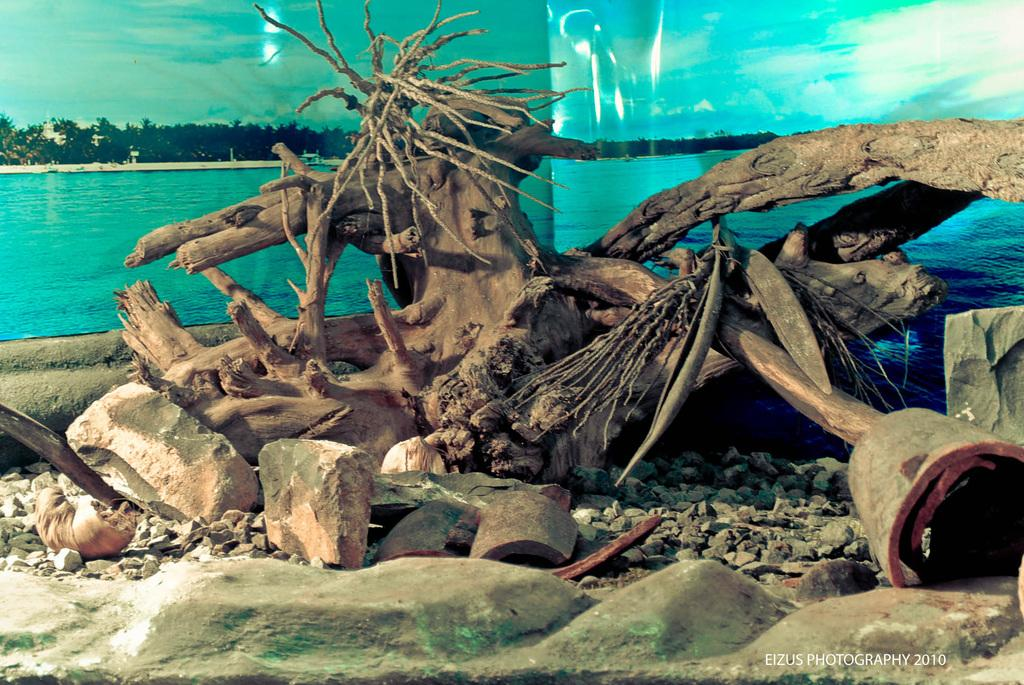What type of natural elements can be seen in the image? Tree trunks, stones, trees, water, ground, and sky are visible in the image. What is the condition of the sky in the image? The sky is visible in the image, and clouds are present. Can you describe the objects in the image? Unfortunately, the provided facts do not specify the nature of the objects in the image. What type of terrain is visible in the image? The image shows a combination of natural elements, including tree trunks, stones, trees, water, and ground. What type of breakfast is being prepared on the tree trunks in the image? There is no indication of any breakfast preparation in the image, as it primarily features natural elements such as tree trunks, stones, trees, water, ground, and sky. 